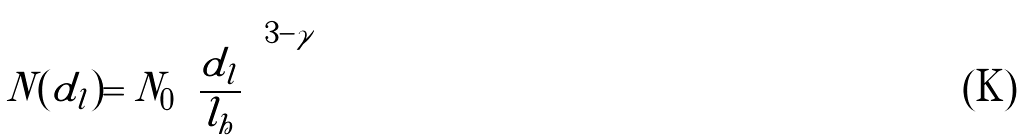Convert formula to latex. <formula><loc_0><loc_0><loc_500><loc_500>N ( { d } _ { l } ) = { N } _ { 0 } { \left ( \frac { { d } _ { l } } { { l } _ { h } } \right ) } ^ { 3 - \gamma }</formula> 